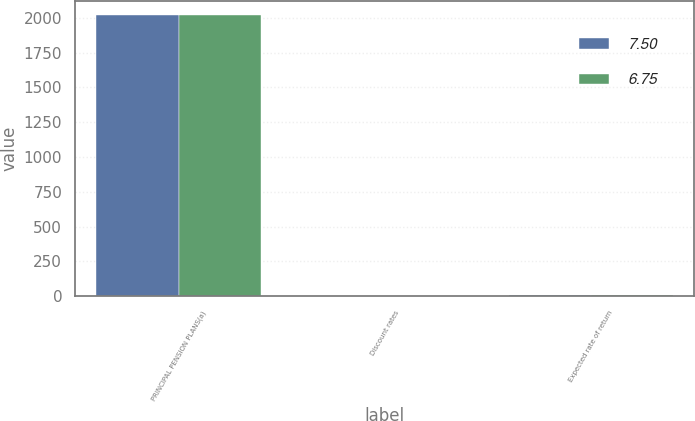<chart> <loc_0><loc_0><loc_500><loc_500><stacked_bar_chart><ecel><fcel>PRINCIPAL PENSION PLANS(a)<fcel>Discount rates<fcel>Expected rate of return<nl><fcel>7.5<fcel>2018<fcel>3.64<fcel>6.75<nl><fcel>6.75<fcel>2017<fcel>4.11<fcel>7.5<nl></chart> 